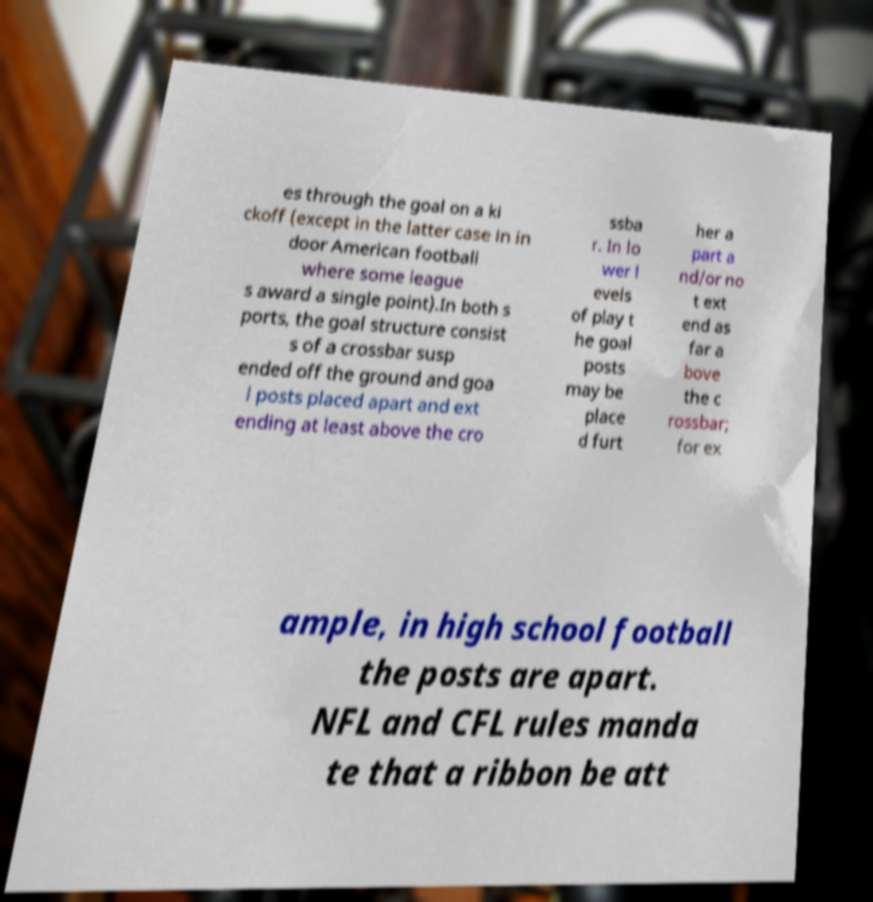Can you accurately transcribe the text from the provided image for me? es through the goal on a ki ckoff (except in the latter case in in door American football where some league s award a single point).In both s ports, the goal structure consist s of a crossbar susp ended off the ground and goa l posts placed apart and ext ending at least above the cro ssba r. In lo wer l evels of play t he goal posts may be place d furt her a part a nd/or no t ext end as far a bove the c rossbar; for ex ample, in high school football the posts are apart. NFL and CFL rules manda te that a ribbon be att 